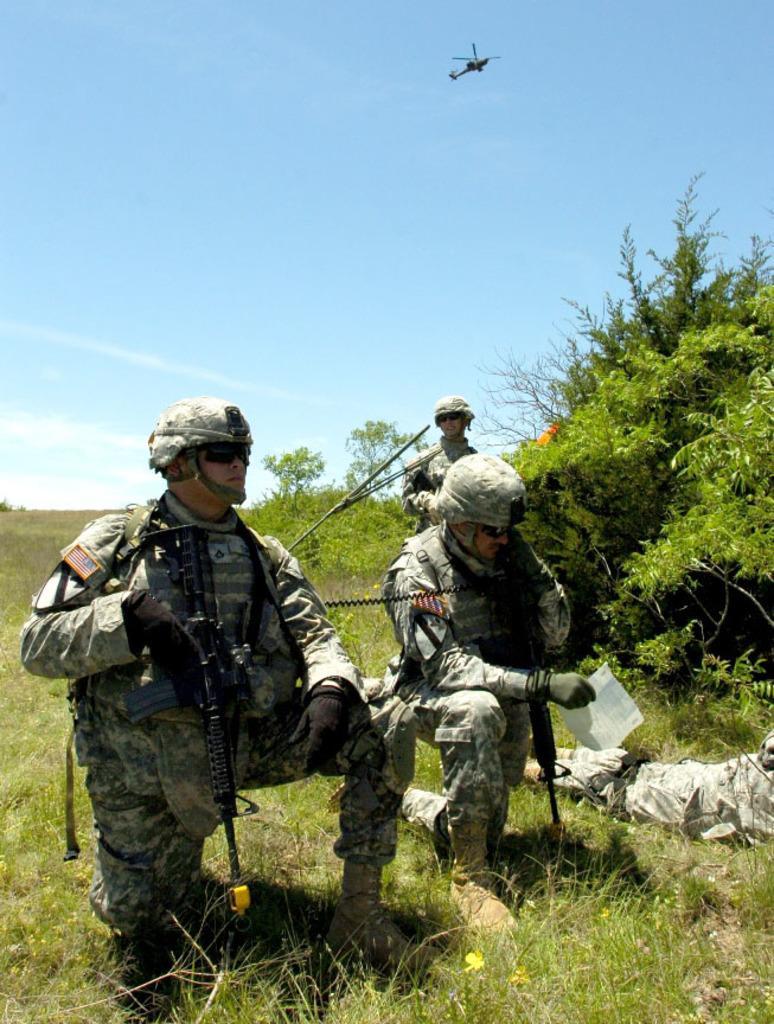Please provide a concise description of this image. On the left side, there is a person in uniform, holding a gun with a hand and kneeling down with a leg on the ground, on which there is grass. On the right side, there is another person in uniform, holding a gun with a hand and kneeling down with a leg on the ground. Beside him, there is another person lying on the ground. In the background, there is another person standing, there are trees, plants and grass on the ground, there is a helicopter in the air and there are clouds in the blue sky. 